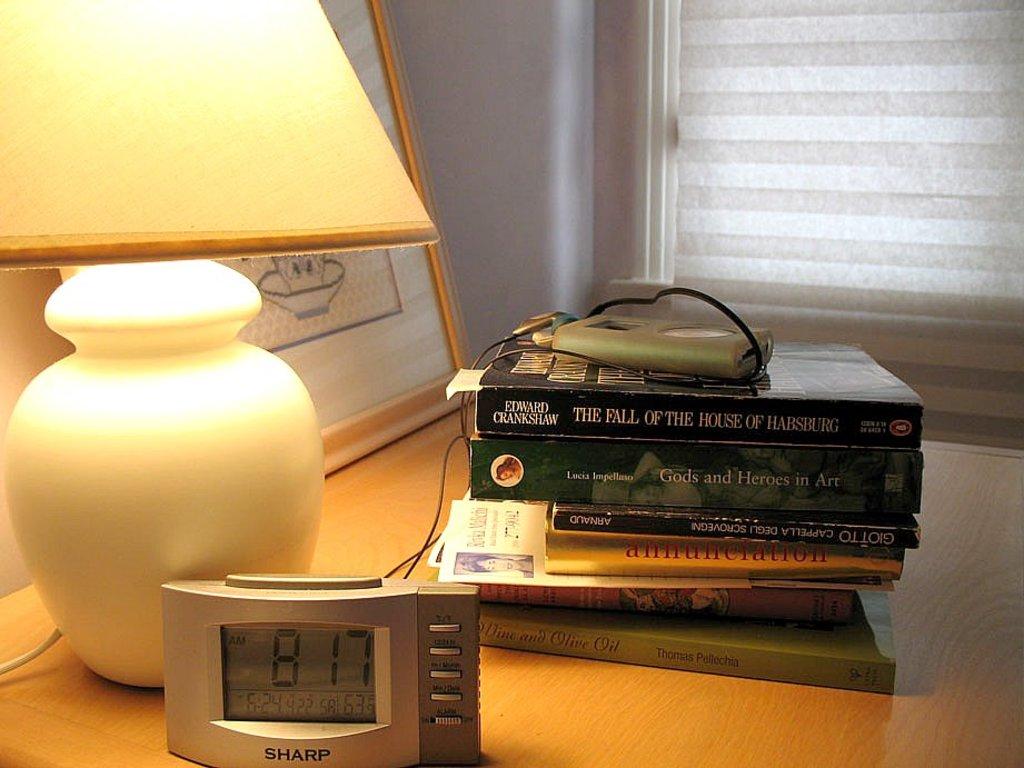What time does the clock show?
Your answer should be very brief. 8:17. What is the top book?
Provide a succinct answer. The fall of the house of habsburg. 